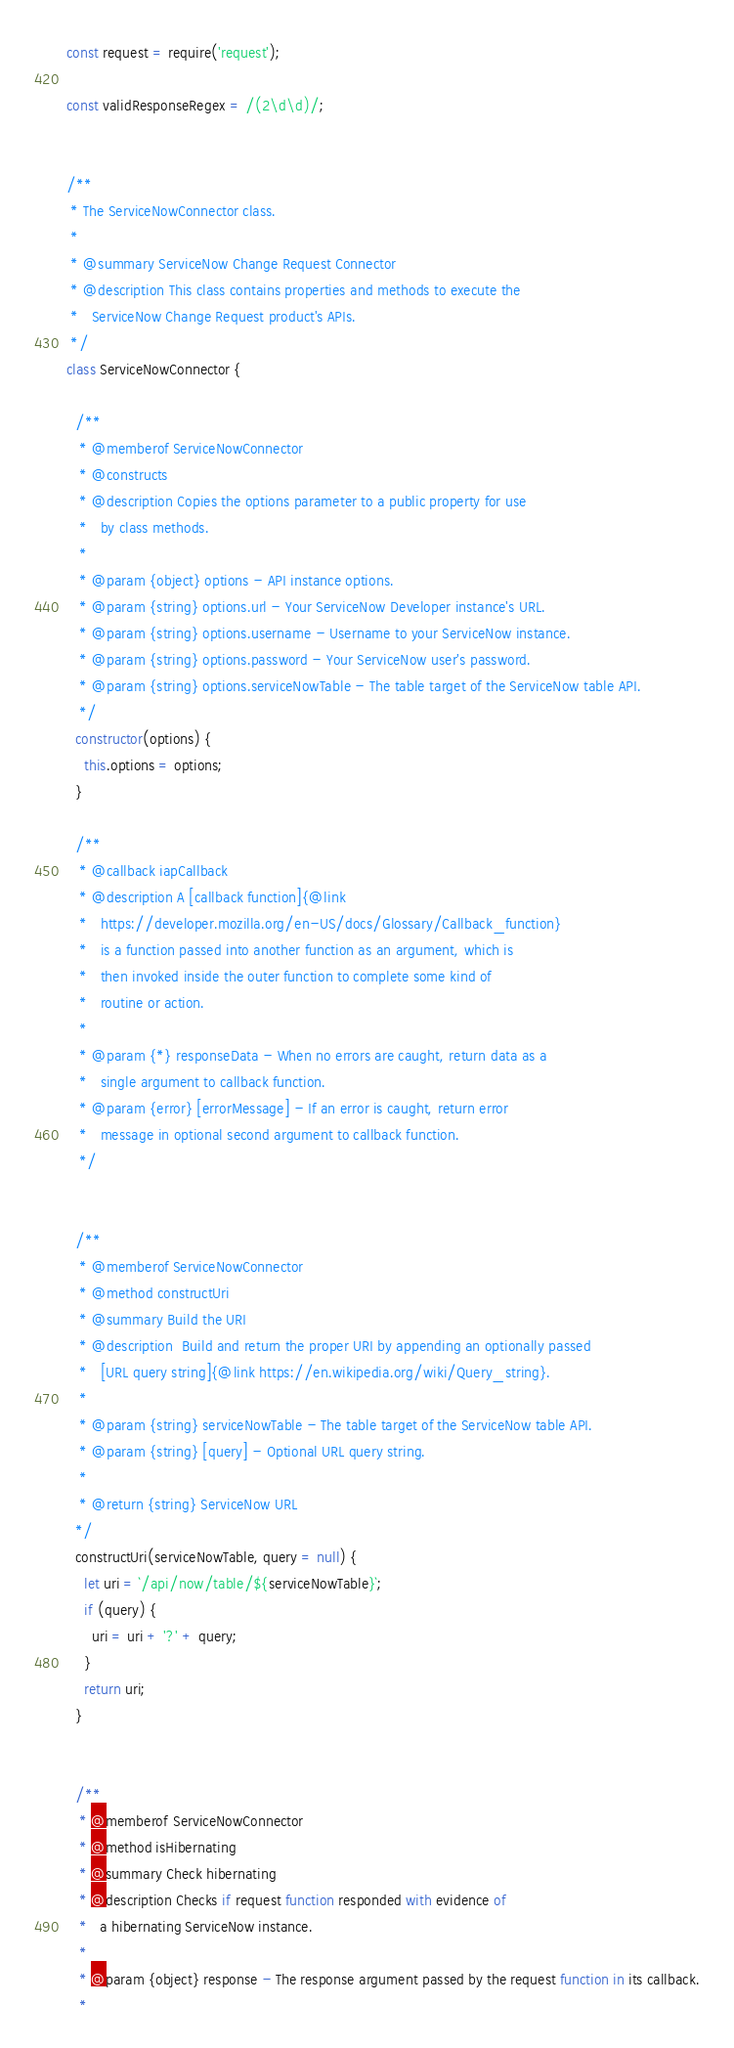<code> <loc_0><loc_0><loc_500><loc_500><_JavaScript_>const request = require('request');

const validResponseRegex = /(2\d\d)/;


/**
 * The ServiceNowConnector class.
 *
 * @summary ServiceNow Change Request Connector
 * @description This class contains properties and methods to execute the
 *   ServiceNow Change Request product's APIs.
 */
class ServiceNowConnector {

  /**
   * @memberof ServiceNowConnector
   * @constructs
   * @description Copies the options parameter to a public property for use
   *   by class methods.
   *
   * @param {object} options - API instance options.
   * @param {string} options.url - Your ServiceNow Developer instance's URL.
   * @param {string} options.username - Username to your ServiceNow instance.
   * @param {string} options.password - Your ServiceNow user's password.
   * @param {string} options.serviceNowTable - The table target of the ServiceNow table API.
   */
  constructor(options) {
    this.options = options;
  }

  /**
   * @callback iapCallback
   * @description A [callback function]{@link
   *   https://developer.mozilla.org/en-US/docs/Glossary/Callback_function}
   *   is a function passed into another function as an argument, which is
   *   then invoked inside the outer function to complete some kind of
   *   routine or action.
   *
   * @param {*} responseData - When no errors are caught, return data as a
   *   single argument to callback function.
   * @param {error} [errorMessage] - If an error is caught, return error
   *   message in optional second argument to callback function.
   */


  /**
   * @memberof ServiceNowConnector
   * @method constructUri
   * @summary Build the URI
   * @description  Build and return the proper URI by appending an optionally passed
   *   [URL query string]{@link https://en.wikipedia.org/wiki/Query_string}.
   *
   * @param {string} serviceNowTable - The table target of the ServiceNow table API.
   * @param {string} [query] - Optional URL query string.
   *
   * @return {string} ServiceNow URL
  */
  constructUri(serviceNowTable, query = null) {
    let uri = `/api/now/table/${serviceNowTable}`;
    if (query) {
      uri = uri + '?' + query;
    }
    return uri;
  }


  /**
   * @memberof ServiceNowConnector
   * @method isHibernating
   * @summary Check hibernating
   * @description Checks if request function responded with evidence of
   *   a hibernating ServiceNow instance.
   *
   * @param {object} response - The response argument passed by the request function in its callback.
   *</code> 